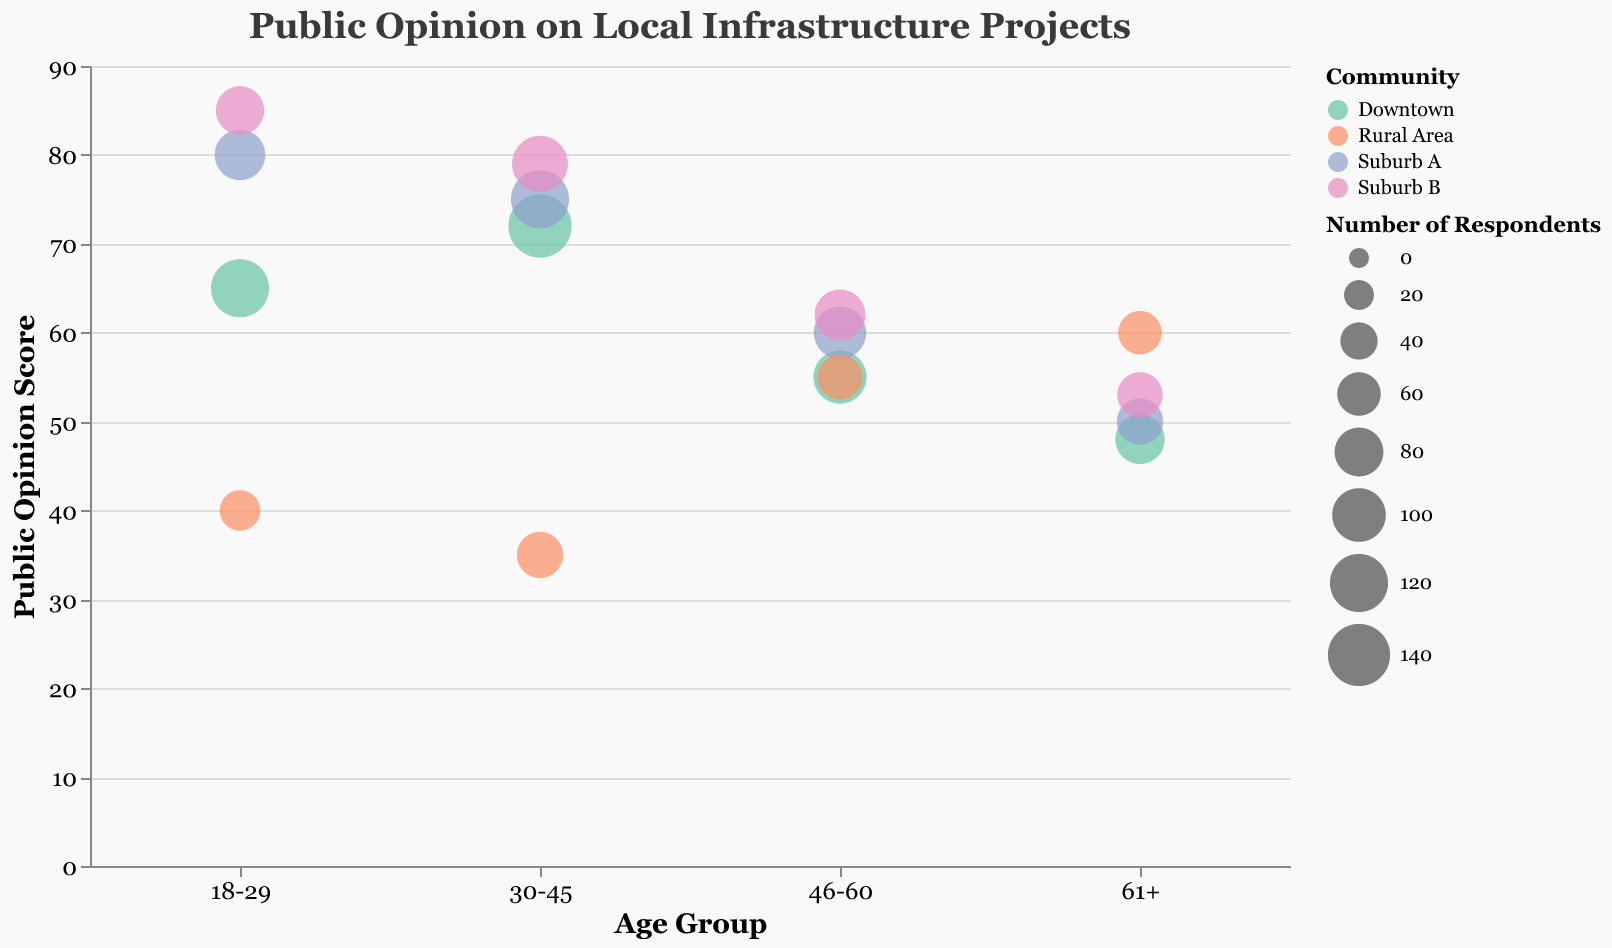What is the title of the figure? The title of the figure is displayed at the top and is "Public Opinion on Local Infrastructure Projects".
Answer: Public Opinion on Local Infrastructure Projects Which age group in Downtown has the highest public opinion score for the New Park Development? The "30-45" age group in Downtown has a public opinion score of 72, which is the highest among the different age groups for the New Park Development project.
Answer: 30-45 Which community has the lowest public opinion score for any project, and what is that score? The Rural Area community has the lowest public opinion score of 35 for the Highway Expansion project in the "30-45" age group.
Answer: Rural Area, 35 What is the average public opinion score for the Community Center Renovation project in Suburb B? The public opinion scores in Suburb B for Community Center Renovation are 85, 79, 62, and 53. The average is calculated as (85 + 79 + 62 + 53) / 4 = 69.75.
Answer: 69.75 Which age group in Suburb A has the highest number of respondents for the Public Transportation Expansion project? The "30-45" age group in Suburb A has the highest number of respondents, with a count of 120.
Answer: 30-45 What is the public opinion score difference between the "18-29" and the "61+" age groups in Downtown for the New Park Development project? For the "18-29" age group, the score is 65, and for the "61+" age group, the score is 48. The difference is calculated as 65 - 48 = 17.
Answer: 17 Which community has the highest public opinion score overall, and which project is it for? The highest public opinion score is 85, found in Suburb B for the Community Center Renovation project in the "18-29" age group.
Answer: Suburb B, Community Center Renovation Comparing the public opinion scores of Suburb A and Rural Area for their respective projects, which community has a more favorable opinion among the "46-60" age group? The "46-60" age group in Suburb A has a public opinion score of 60 for the Public Transportation Expansion project, while in the Rural Area, the same age group has a score of 55 for the Highway Expansion project. Suburb A's score is higher.
Answer: Suburb A In the "61+" age group, does any community have a higher public opinion score than the Downtown community's score for the New Park Development project? The "61+" age group's public opinion score in Downtown for the New Park Development project is 48. Suburb A has 50, Suburb B has 53, and Rural Area has 60, all of which are higher.
Answer: Yes In Suburb B, which age group showed the lowest public opinion score for the Community Center Renovation project, and what is that score? In Suburb B, the "61+" age group has the lowest public opinion score for the Community Center Renovation project, with a score of 53.
Answer: 61+, 53 